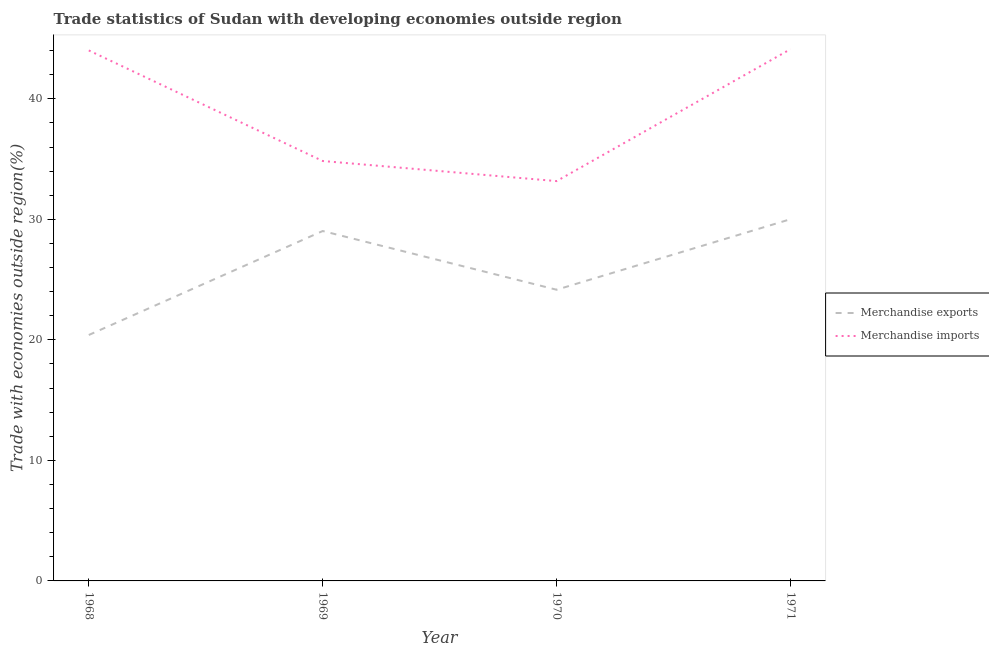How many different coloured lines are there?
Give a very brief answer. 2. Does the line corresponding to merchandise imports intersect with the line corresponding to merchandise exports?
Ensure brevity in your answer.  No. What is the merchandise exports in 1969?
Keep it short and to the point. 29.03. Across all years, what is the maximum merchandise imports?
Make the answer very short. 44.12. Across all years, what is the minimum merchandise exports?
Make the answer very short. 20.4. What is the total merchandise imports in the graph?
Your answer should be compact. 156.15. What is the difference between the merchandise exports in 1968 and that in 1970?
Provide a short and direct response. -3.76. What is the difference between the merchandise imports in 1969 and the merchandise exports in 1968?
Your response must be concise. 14.44. What is the average merchandise exports per year?
Provide a succinct answer. 25.9. In the year 1970, what is the difference between the merchandise exports and merchandise imports?
Offer a terse response. -9.01. What is the ratio of the merchandise imports in 1968 to that in 1970?
Provide a succinct answer. 1.33. Is the merchandise imports in 1969 less than that in 1970?
Keep it short and to the point. No. Is the difference between the merchandise exports in 1969 and 1971 greater than the difference between the merchandise imports in 1969 and 1971?
Provide a succinct answer. Yes. What is the difference between the highest and the second highest merchandise imports?
Ensure brevity in your answer.  0.1. What is the difference between the highest and the lowest merchandise exports?
Make the answer very short. 9.61. Is the sum of the merchandise exports in 1968 and 1970 greater than the maximum merchandise imports across all years?
Offer a terse response. Yes. Does the merchandise exports monotonically increase over the years?
Provide a succinct answer. No. Is the merchandise imports strictly less than the merchandise exports over the years?
Your answer should be very brief. No. How many lines are there?
Make the answer very short. 2. Are the values on the major ticks of Y-axis written in scientific E-notation?
Keep it short and to the point. No. Does the graph contain grids?
Keep it short and to the point. No. How many legend labels are there?
Your answer should be very brief. 2. How are the legend labels stacked?
Your response must be concise. Vertical. What is the title of the graph?
Offer a very short reply. Trade statistics of Sudan with developing economies outside region. Does "Under-5(male)" appear as one of the legend labels in the graph?
Your response must be concise. No. What is the label or title of the X-axis?
Give a very brief answer. Year. What is the label or title of the Y-axis?
Offer a very short reply. Trade with economies outside region(%). What is the Trade with economies outside region(%) of Merchandise exports in 1968?
Ensure brevity in your answer.  20.4. What is the Trade with economies outside region(%) in Merchandise imports in 1968?
Keep it short and to the point. 44.02. What is the Trade with economies outside region(%) in Merchandise exports in 1969?
Provide a short and direct response. 29.03. What is the Trade with economies outside region(%) in Merchandise imports in 1969?
Provide a short and direct response. 34.84. What is the Trade with economies outside region(%) in Merchandise exports in 1970?
Give a very brief answer. 24.16. What is the Trade with economies outside region(%) of Merchandise imports in 1970?
Offer a very short reply. 33.17. What is the Trade with economies outside region(%) in Merchandise exports in 1971?
Your answer should be very brief. 30.01. What is the Trade with economies outside region(%) in Merchandise imports in 1971?
Give a very brief answer. 44.12. Across all years, what is the maximum Trade with economies outside region(%) in Merchandise exports?
Your answer should be very brief. 30.01. Across all years, what is the maximum Trade with economies outside region(%) in Merchandise imports?
Keep it short and to the point. 44.12. Across all years, what is the minimum Trade with economies outside region(%) of Merchandise exports?
Your response must be concise. 20.4. Across all years, what is the minimum Trade with economies outside region(%) of Merchandise imports?
Your answer should be very brief. 33.17. What is the total Trade with economies outside region(%) in Merchandise exports in the graph?
Offer a terse response. 103.61. What is the total Trade with economies outside region(%) of Merchandise imports in the graph?
Your answer should be very brief. 156.15. What is the difference between the Trade with economies outside region(%) in Merchandise exports in 1968 and that in 1969?
Provide a succinct answer. -8.63. What is the difference between the Trade with economies outside region(%) of Merchandise imports in 1968 and that in 1969?
Ensure brevity in your answer.  9.17. What is the difference between the Trade with economies outside region(%) of Merchandise exports in 1968 and that in 1970?
Provide a succinct answer. -3.76. What is the difference between the Trade with economies outside region(%) of Merchandise imports in 1968 and that in 1970?
Your answer should be very brief. 10.84. What is the difference between the Trade with economies outside region(%) in Merchandise exports in 1968 and that in 1971?
Your answer should be compact. -9.61. What is the difference between the Trade with economies outside region(%) of Merchandise imports in 1968 and that in 1971?
Your answer should be very brief. -0.1. What is the difference between the Trade with economies outside region(%) of Merchandise exports in 1969 and that in 1970?
Ensure brevity in your answer.  4.87. What is the difference between the Trade with economies outside region(%) in Merchandise imports in 1969 and that in 1970?
Give a very brief answer. 1.67. What is the difference between the Trade with economies outside region(%) of Merchandise exports in 1969 and that in 1971?
Ensure brevity in your answer.  -0.98. What is the difference between the Trade with economies outside region(%) in Merchandise imports in 1969 and that in 1971?
Ensure brevity in your answer.  -9.28. What is the difference between the Trade with economies outside region(%) in Merchandise exports in 1970 and that in 1971?
Offer a very short reply. -5.85. What is the difference between the Trade with economies outside region(%) of Merchandise imports in 1970 and that in 1971?
Ensure brevity in your answer.  -10.95. What is the difference between the Trade with economies outside region(%) in Merchandise exports in 1968 and the Trade with economies outside region(%) in Merchandise imports in 1969?
Ensure brevity in your answer.  -14.44. What is the difference between the Trade with economies outside region(%) in Merchandise exports in 1968 and the Trade with economies outside region(%) in Merchandise imports in 1970?
Provide a succinct answer. -12.77. What is the difference between the Trade with economies outside region(%) of Merchandise exports in 1968 and the Trade with economies outside region(%) of Merchandise imports in 1971?
Your response must be concise. -23.72. What is the difference between the Trade with economies outside region(%) in Merchandise exports in 1969 and the Trade with economies outside region(%) in Merchandise imports in 1970?
Your answer should be very brief. -4.14. What is the difference between the Trade with economies outside region(%) of Merchandise exports in 1969 and the Trade with economies outside region(%) of Merchandise imports in 1971?
Offer a very short reply. -15.09. What is the difference between the Trade with economies outside region(%) in Merchandise exports in 1970 and the Trade with economies outside region(%) in Merchandise imports in 1971?
Offer a terse response. -19.96. What is the average Trade with economies outside region(%) of Merchandise exports per year?
Your answer should be compact. 25.9. What is the average Trade with economies outside region(%) in Merchandise imports per year?
Your response must be concise. 39.04. In the year 1968, what is the difference between the Trade with economies outside region(%) of Merchandise exports and Trade with economies outside region(%) of Merchandise imports?
Give a very brief answer. -23.61. In the year 1969, what is the difference between the Trade with economies outside region(%) of Merchandise exports and Trade with economies outside region(%) of Merchandise imports?
Your answer should be compact. -5.81. In the year 1970, what is the difference between the Trade with economies outside region(%) of Merchandise exports and Trade with economies outside region(%) of Merchandise imports?
Offer a terse response. -9.01. In the year 1971, what is the difference between the Trade with economies outside region(%) in Merchandise exports and Trade with economies outside region(%) in Merchandise imports?
Keep it short and to the point. -14.11. What is the ratio of the Trade with economies outside region(%) in Merchandise exports in 1968 to that in 1969?
Provide a succinct answer. 0.7. What is the ratio of the Trade with economies outside region(%) in Merchandise imports in 1968 to that in 1969?
Ensure brevity in your answer.  1.26. What is the ratio of the Trade with economies outside region(%) of Merchandise exports in 1968 to that in 1970?
Offer a terse response. 0.84. What is the ratio of the Trade with economies outside region(%) of Merchandise imports in 1968 to that in 1970?
Your response must be concise. 1.33. What is the ratio of the Trade with economies outside region(%) in Merchandise exports in 1968 to that in 1971?
Keep it short and to the point. 0.68. What is the ratio of the Trade with economies outside region(%) of Merchandise imports in 1968 to that in 1971?
Provide a succinct answer. 1. What is the ratio of the Trade with economies outside region(%) in Merchandise exports in 1969 to that in 1970?
Ensure brevity in your answer.  1.2. What is the ratio of the Trade with economies outside region(%) in Merchandise imports in 1969 to that in 1970?
Offer a terse response. 1.05. What is the ratio of the Trade with economies outside region(%) in Merchandise exports in 1969 to that in 1971?
Provide a short and direct response. 0.97. What is the ratio of the Trade with economies outside region(%) in Merchandise imports in 1969 to that in 1971?
Your answer should be compact. 0.79. What is the ratio of the Trade with economies outside region(%) of Merchandise exports in 1970 to that in 1971?
Keep it short and to the point. 0.81. What is the ratio of the Trade with economies outside region(%) of Merchandise imports in 1970 to that in 1971?
Your answer should be compact. 0.75. What is the difference between the highest and the second highest Trade with economies outside region(%) in Merchandise exports?
Ensure brevity in your answer.  0.98. What is the difference between the highest and the second highest Trade with economies outside region(%) in Merchandise imports?
Your answer should be very brief. 0.1. What is the difference between the highest and the lowest Trade with economies outside region(%) of Merchandise exports?
Give a very brief answer. 9.61. What is the difference between the highest and the lowest Trade with economies outside region(%) in Merchandise imports?
Offer a very short reply. 10.95. 